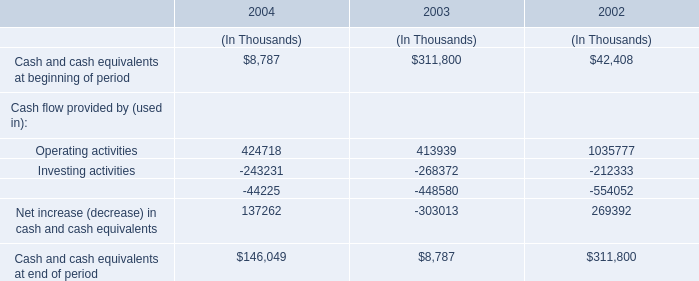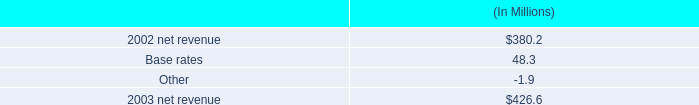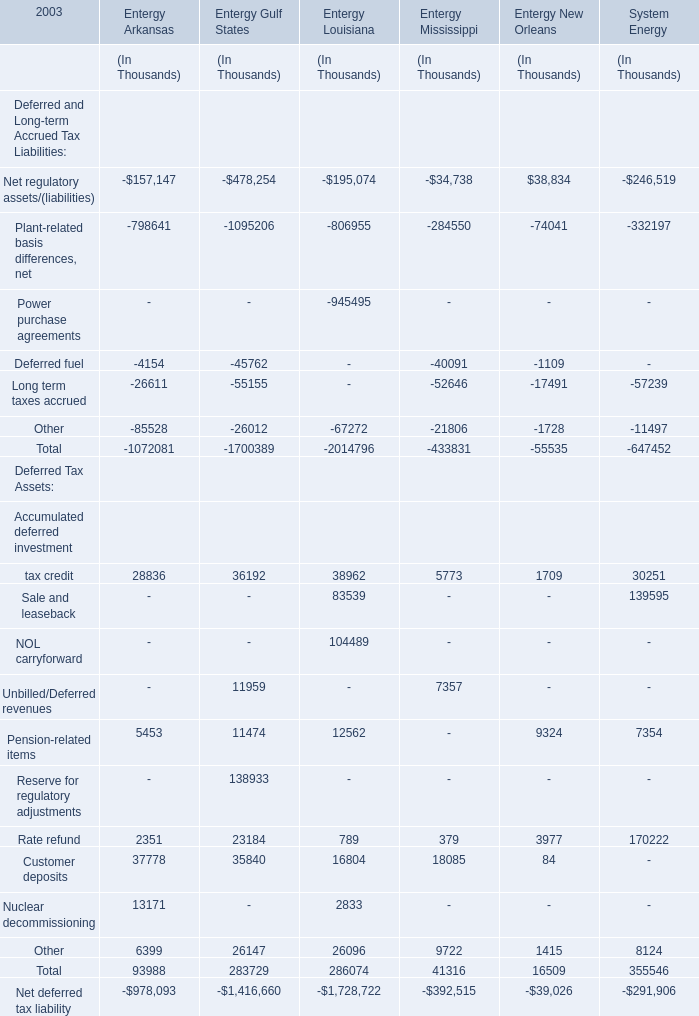What's the sum of all Deferred Tax Assets that are positive in2003 for Entergy Arkansas? (in thousand) 
Computations: (((((28836 + 5453) + 2351) + 37778) + 13171) + 6399)
Answer: 93988.0. 